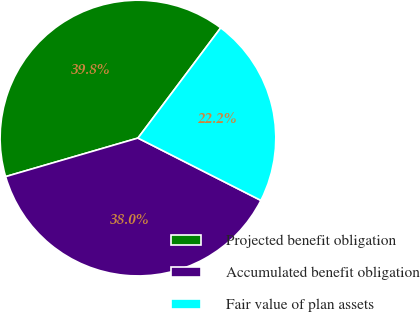Convert chart. <chart><loc_0><loc_0><loc_500><loc_500><pie_chart><fcel>Projected benefit obligation<fcel>Accumulated benefit obligation<fcel>Fair value of plan assets<nl><fcel>39.76%<fcel>38.02%<fcel>22.22%<nl></chart> 